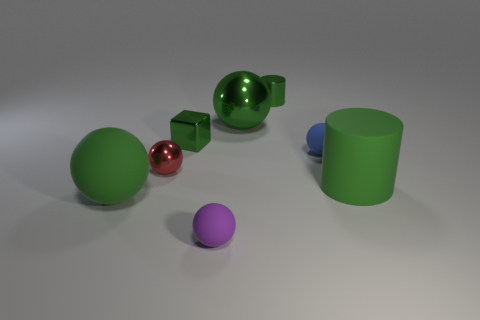How many green balls must be subtracted to get 1 green balls? 1 Subtract all small shiny spheres. How many spheres are left? 4 Subtract all green spheres. How many spheres are left? 3 Add 1 green rubber cylinders. How many objects exist? 9 Subtract all cylinders. How many objects are left? 6 Subtract all small purple spheres. Subtract all purple objects. How many objects are left? 6 Add 8 small red things. How many small red things are left? 9 Add 1 green things. How many green things exist? 6 Subtract 0 yellow cylinders. How many objects are left? 8 Subtract all gray cylinders. Subtract all purple cubes. How many cylinders are left? 2 